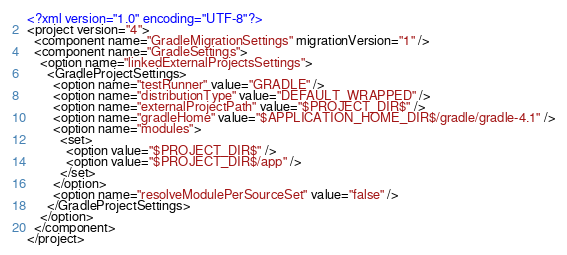<code> <loc_0><loc_0><loc_500><loc_500><_XML_><?xml version="1.0" encoding="UTF-8"?>
<project version="4">
  <component name="GradleMigrationSettings" migrationVersion="1" />
  <component name="GradleSettings">
    <option name="linkedExternalProjectsSettings">
      <GradleProjectSettings>
        <option name="testRunner" value="GRADLE" />
        <option name="distributionType" value="DEFAULT_WRAPPED" />
        <option name="externalProjectPath" value="$PROJECT_DIR$" />
        <option name="gradleHome" value="$APPLICATION_HOME_DIR$/gradle/gradle-4.1" />
        <option name="modules">
          <set>
            <option value="$PROJECT_DIR$" />
            <option value="$PROJECT_DIR$/app" />
          </set>
        </option>
        <option name="resolveModulePerSourceSet" value="false" />
      </GradleProjectSettings>
    </option>
  </component>
</project></code> 